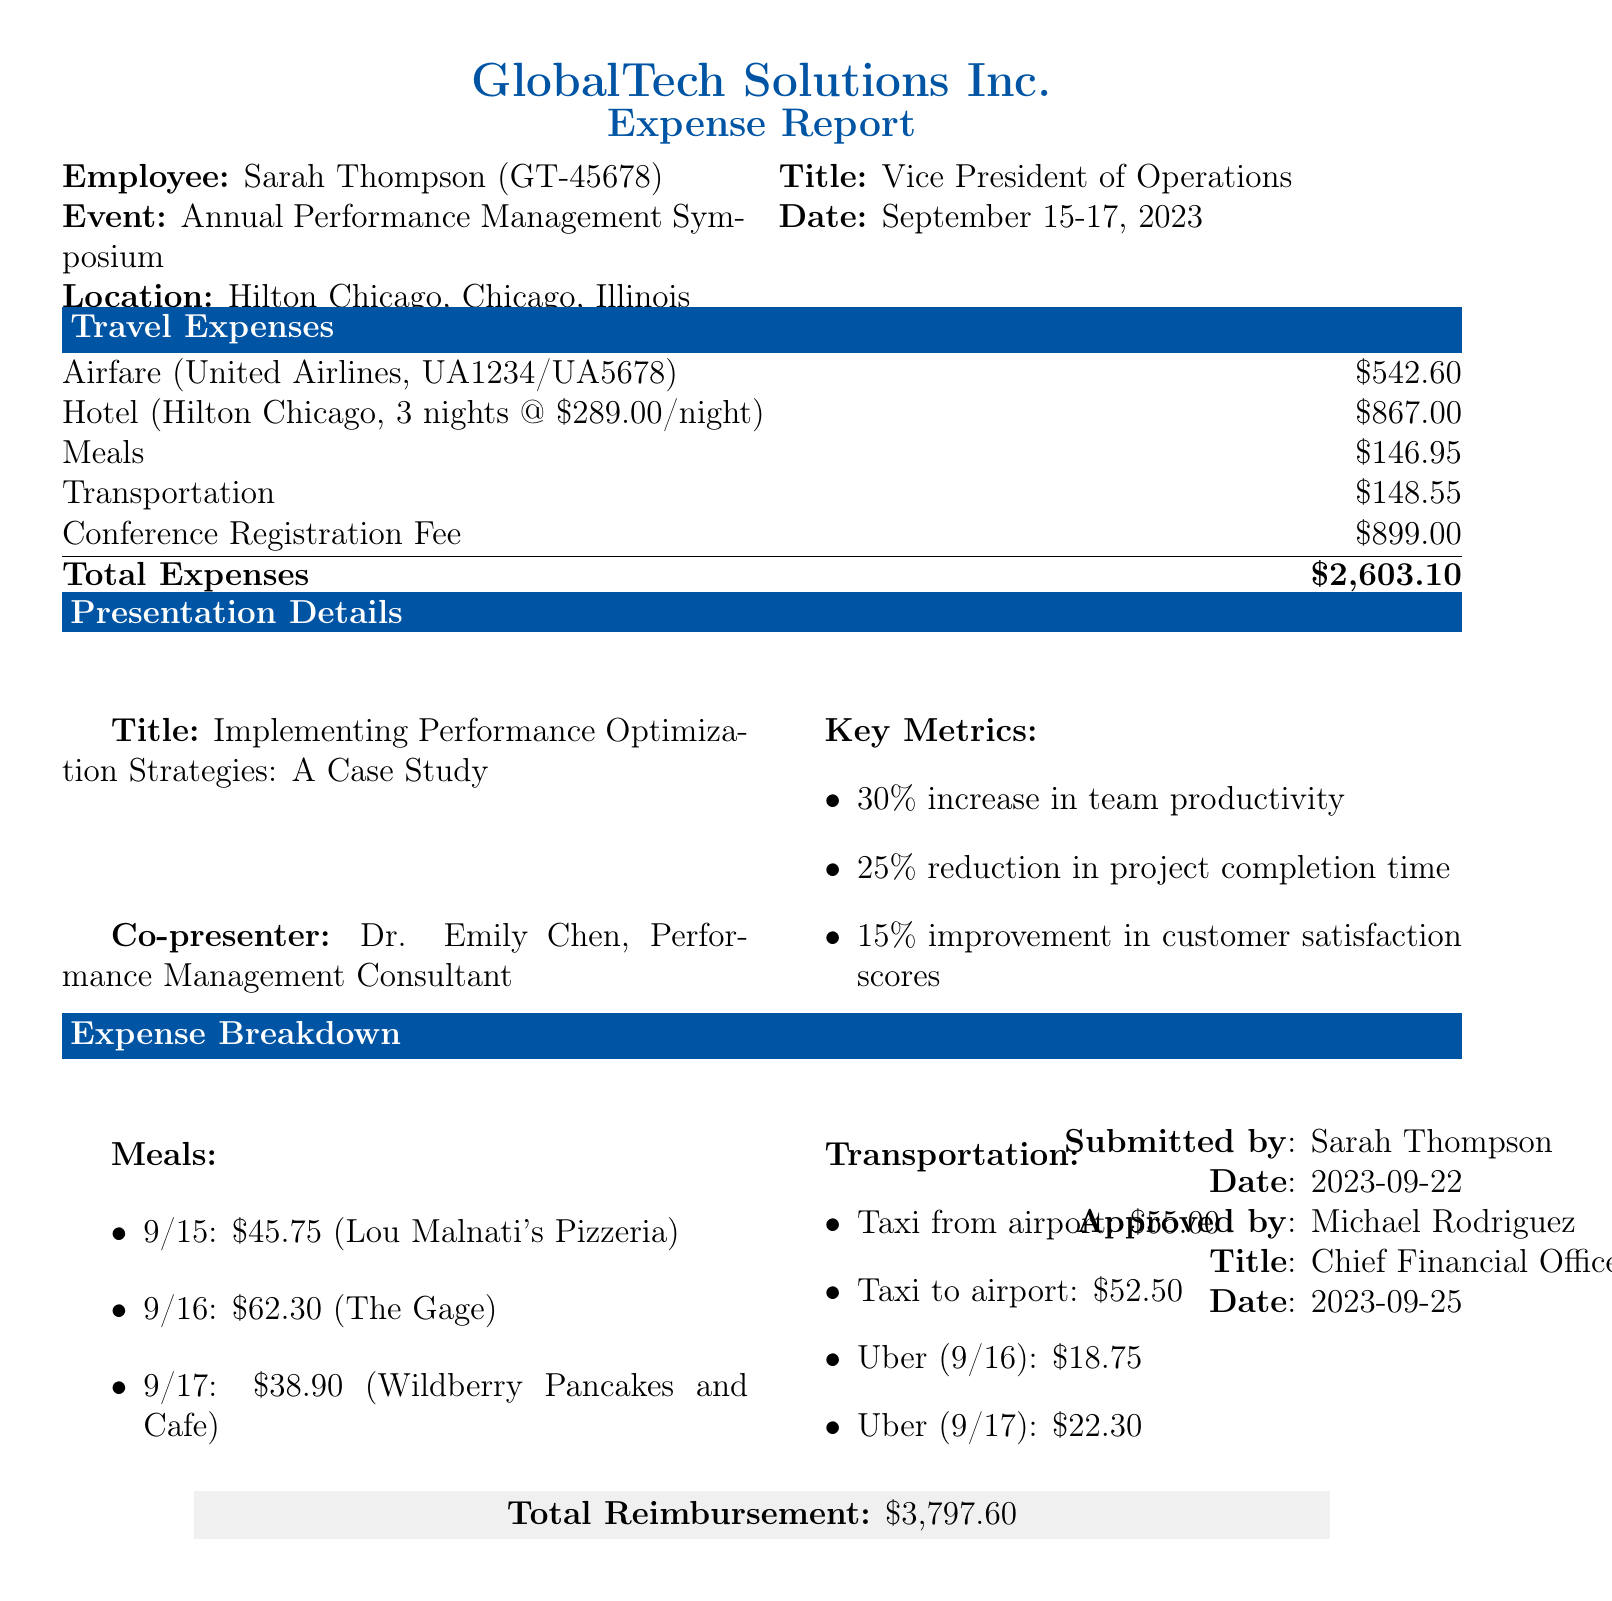What is the name of the traveler? The traveler's name is mentioned in the "traveler_info" section of the document.
Answer: Sarah Thompson What was the conference location? The conference location is specified in the "conference_details" section of the document.
Answer: Hilton Chicago, Chicago, Illinois How much did the transportation cost in total? The total transportation cost is detailed in the "travel_expenses" section.
Answer: 148.55 Who approved the expense report? The approver's name is listed under "approval_info" in the document.
Answer: Michael Rodriguez What is the total reimbursement amount? The total reimbursement amount is summarized in the "expense_summary" section.
Answer: 3,797.60 What is the title of the presentation? The presentation title is found in the "presentation_details" section of the document.
Answer: Implementing Performance Optimization Strategies: A Case Study How many nights did the traveler stay at the hotel? The number of nights stayed is specified in the "hotel" section under "travel_expenses".
Answer: 3 What key metric shows improvement in customer satisfaction scores? The improvement in customer satisfaction scores is included in the "key_metrics" under "presentation_details".
Answer: 15% improvement What date was the expense report submitted? The submission date is mentioned in the "approval_info" section of the document.
Answer: 2023-09-22 